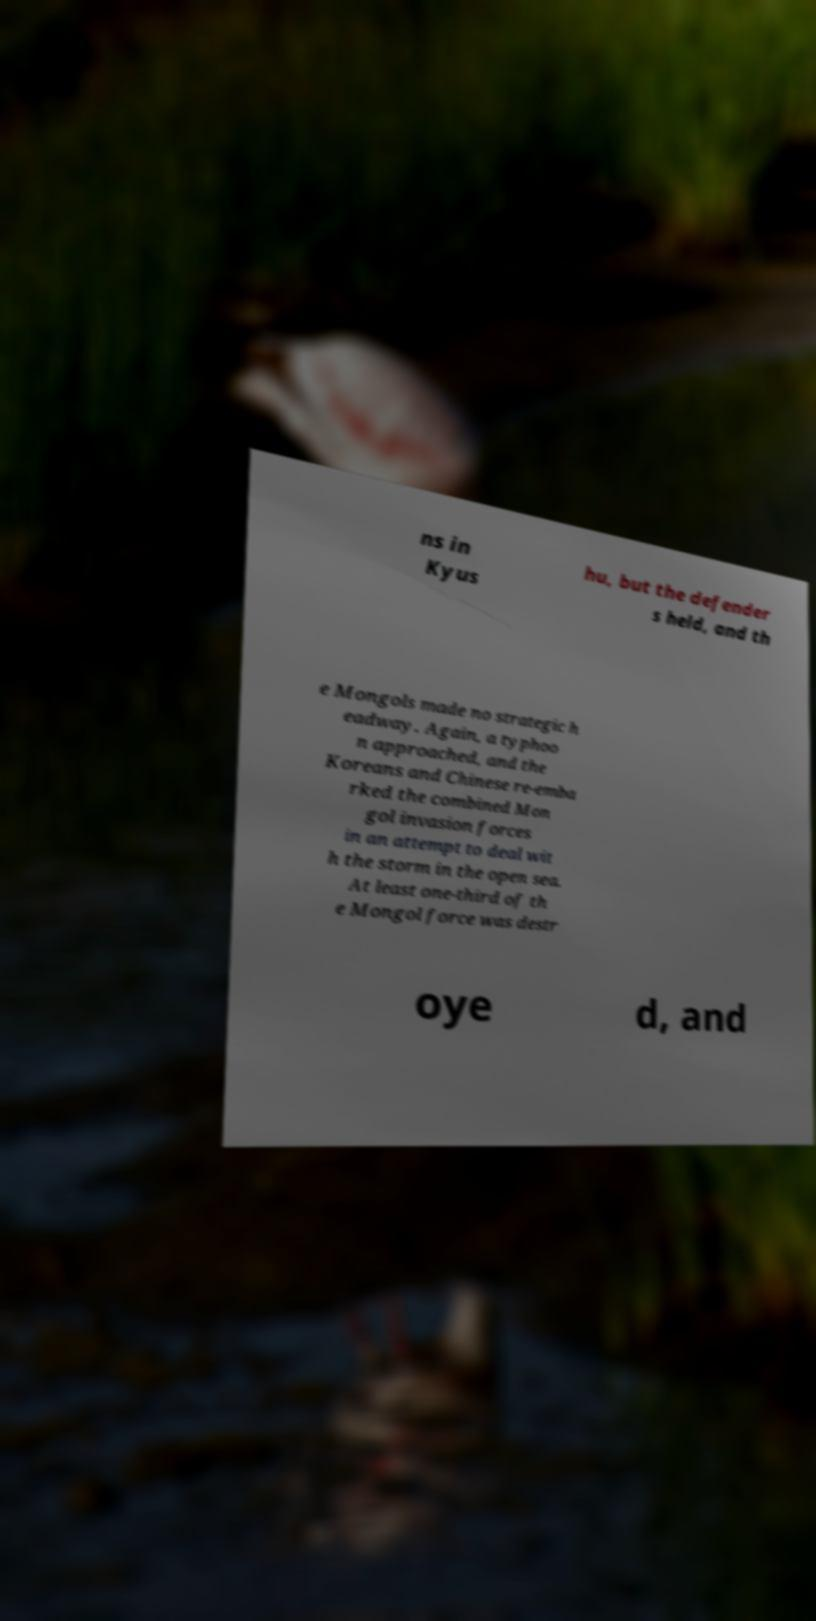Please identify and transcribe the text found in this image. ns in Kyus hu, but the defender s held, and th e Mongols made no strategic h eadway. Again, a typhoo n approached, and the Koreans and Chinese re-emba rked the combined Mon gol invasion forces in an attempt to deal wit h the storm in the open sea. At least one-third of th e Mongol force was destr oye d, and 